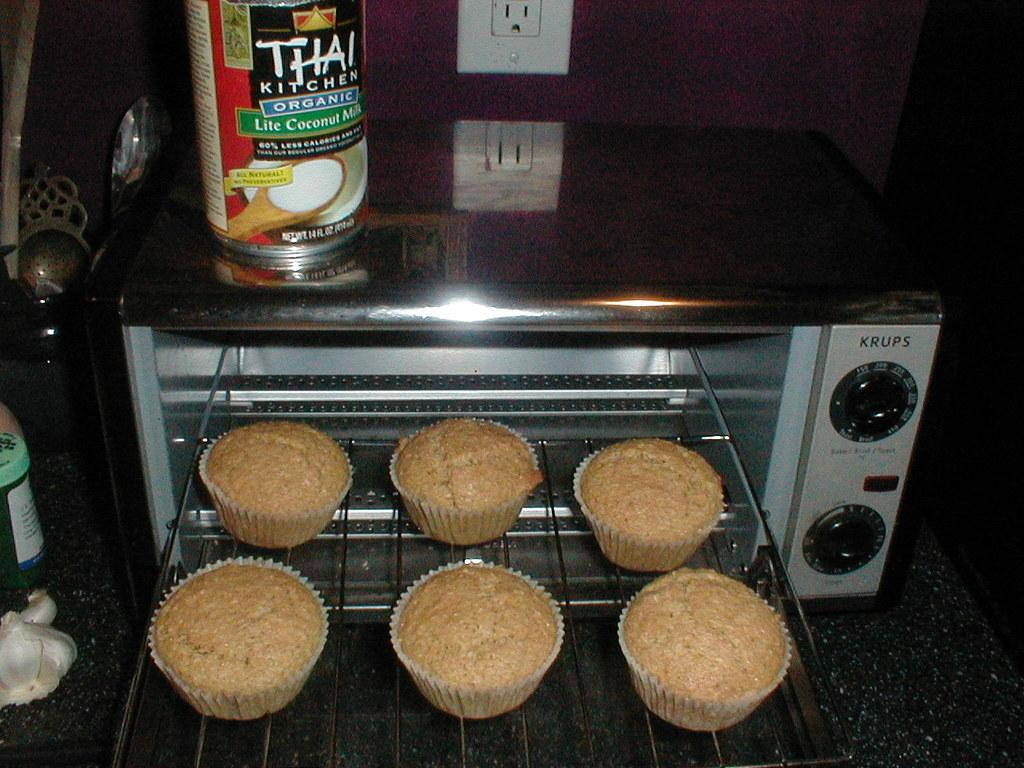<image>
Share a concise interpretation of the image provided. Six cupcakes are in an open convection oven that says Krups. 